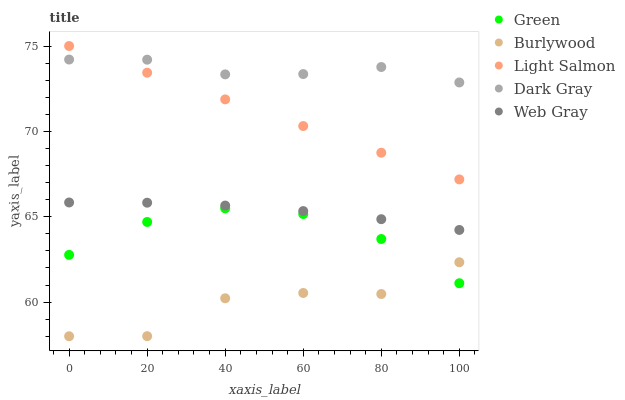Does Burlywood have the minimum area under the curve?
Answer yes or no. Yes. Does Dark Gray have the maximum area under the curve?
Answer yes or no. Yes. Does Light Salmon have the minimum area under the curve?
Answer yes or no. No. Does Light Salmon have the maximum area under the curve?
Answer yes or no. No. Is Light Salmon the smoothest?
Answer yes or no. Yes. Is Burlywood the roughest?
Answer yes or no. Yes. Is Dark Gray the smoothest?
Answer yes or no. No. Is Dark Gray the roughest?
Answer yes or no. No. Does Burlywood have the lowest value?
Answer yes or no. Yes. Does Light Salmon have the lowest value?
Answer yes or no. No. Does Light Salmon have the highest value?
Answer yes or no. Yes. Does Dark Gray have the highest value?
Answer yes or no. No. Is Web Gray less than Dark Gray?
Answer yes or no. Yes. Is Light Salmon greater than Green?
Answer yes or no. Yes. Does Dark Gray intersect Light Salmon?
Answer yes or no. Yes. Is Dark Gray less than Light Salmon?
Answer yes or no. No. Is Dark Gray greater than Light Salmon?
Answer yes or no. No. Does Web Gray intersect Dark Gray?
Answer yes or no. No. 